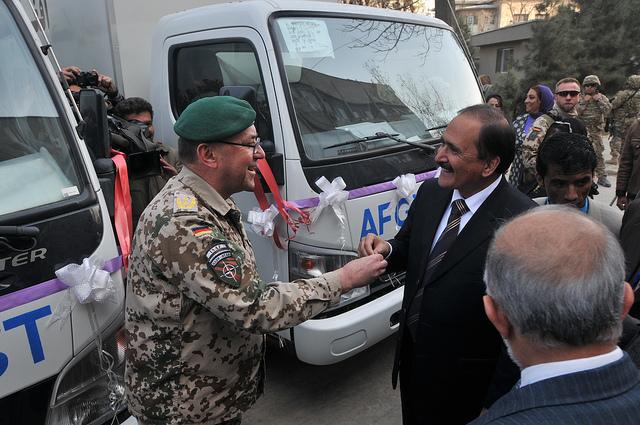Does the man in the foreground have trimmed neck hair?
Be succinct. Yes. Are they kissing fingers?
Be succinct. No. Is a man in the military?
Concise answer only. Yes. 